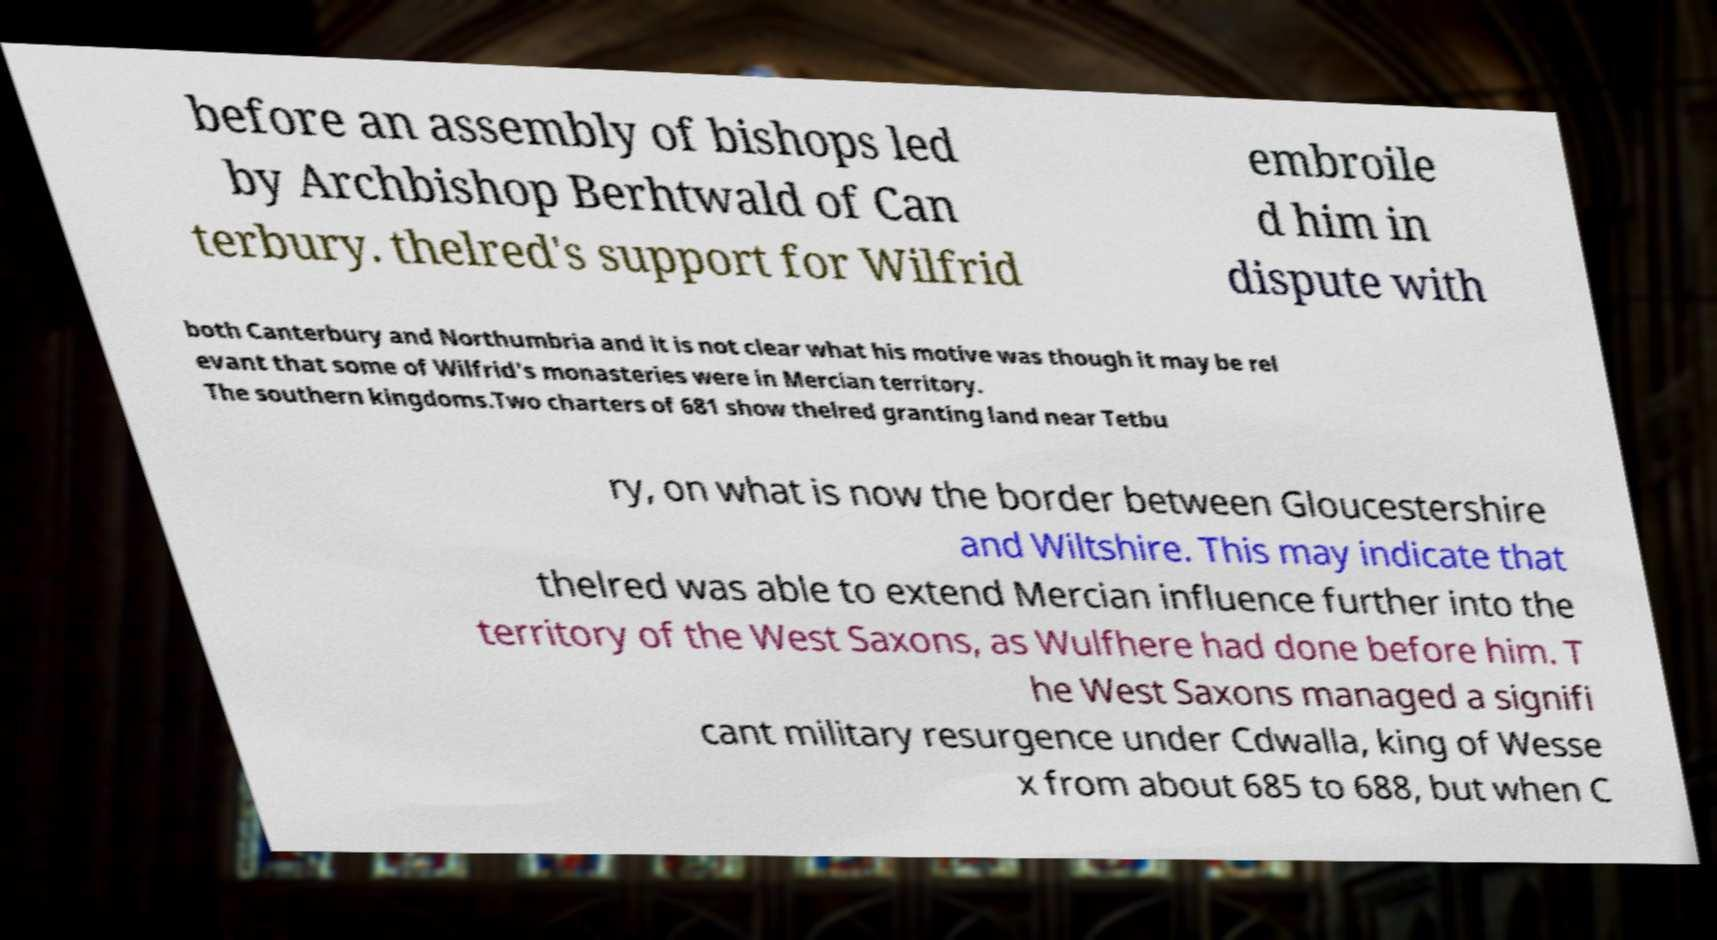For documentation purposes, I need the text within this image transcribed. Could you provide that? before an assembly of bishops led by Archbishop Berhtwald of Can terbury. thelred's support for Wilfrid embroile d him in dispute with both Canterbury and Northumbria and it is not clear what his motive was though it may be rel evant that some of Wilfrid's monasteries were in Mercian territory. The southern kingdoms.Two charters of 681 show thelred granting land near Tetbu ry, on what is now the border between Gloucestershire and Wiltshire. This may indicate that thelred was able to extend Mercian influence further into the territory of the West Saxons, as Wulfhere had done before him. T he West Saxons managed a signifi cant military resurgence under Cdwalla, king of Wesse x from about 685 to 688, but when C 